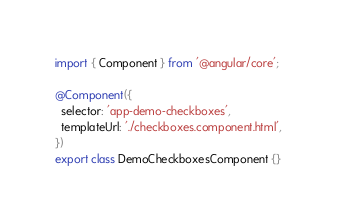Convert code to text. <code><loc_0><loc_0><loc_500><loc_500><_TypeScript_>import { Component } from '@angular/core';

@Component({
  selector: 'app-demo-checkboxes',
  templateUrl: './checkboxes.component.html',
})
export class DemoCheckboxesComponent {}
</code> 